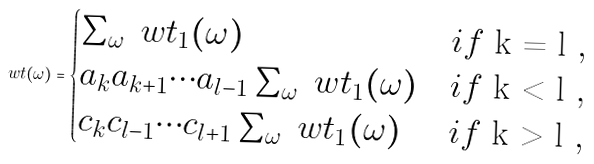Convert formula to latex. <formula><loc_0><loc_0><loc_500><loc_500>\ w t ( \omega ) = \begin{cases} \sum _ { \omega } \ w t _ { 1 } ( \omega ) & i f $ k = l $ , \\ a _ { k } a _ { k + 1 } \cdots a _ { l - 1 } \sum _ { \omega } \ w t _ { 1 } ( \omega ) & i f $ k < l $ , \\ c _ { k } c _ { l - 1 } \cdots c _ { l + 1 } \sum _ { \omega } \ w t _ { 1 } ( \omega ) & i f $ k > l $ , \\ \end{cases}</formula> 